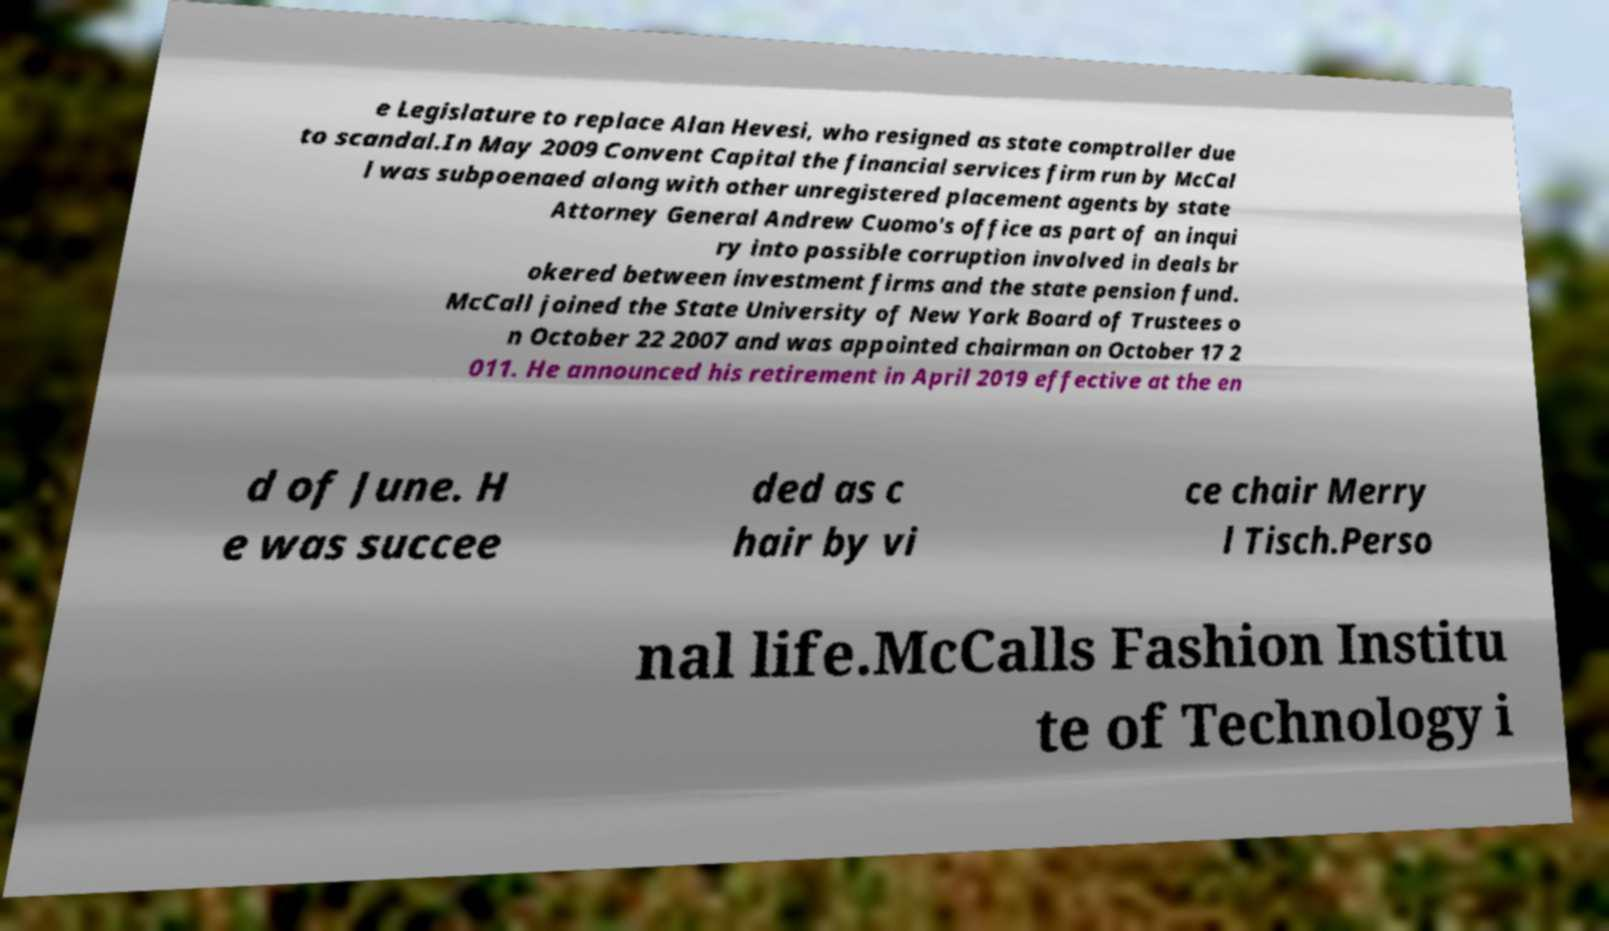For documentation purposes, I need the text within this image transcribed. Could you provide that? e Legislature to replace Alan Hevesi, who resigned as state comptroller due to scandal.In May 2009 Convent Capital the financial services firm run by McCal l was subpoenaed along with other unregistered placement agents by state Attorney General Andrew Cuomo's office as part of an inqui ry into possible corruption involved in deals br okered between investment firms and the state pension fund. McCall joined the State University of New York Board of Trustees o n October 22 2007 and was appointed chairman on October 17 2 011. He announced his retirement in April 2019 effective at the en d of June. H e was succee ded as c hair by vi ce chair Merry l Tisch.Perso nal life.McCalls Fashion Institu te of Technology i 